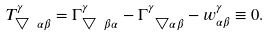Convert formula to latex. <formula><loc_0><loc_0><loc_500><loc_500>T _ { \bigtriangledown \ \alpha \beta } ^ { \gamma } = \Gamma _ { \bigtriangledown \ \beta \alpha } ^ { \gamma } - \Gamma _ { \ \bigtriangledown \alpha \beta } ^ { \gamma } - w _ { \alpha \beta } ^ { \gamma } \equiv 0 .</formula> 